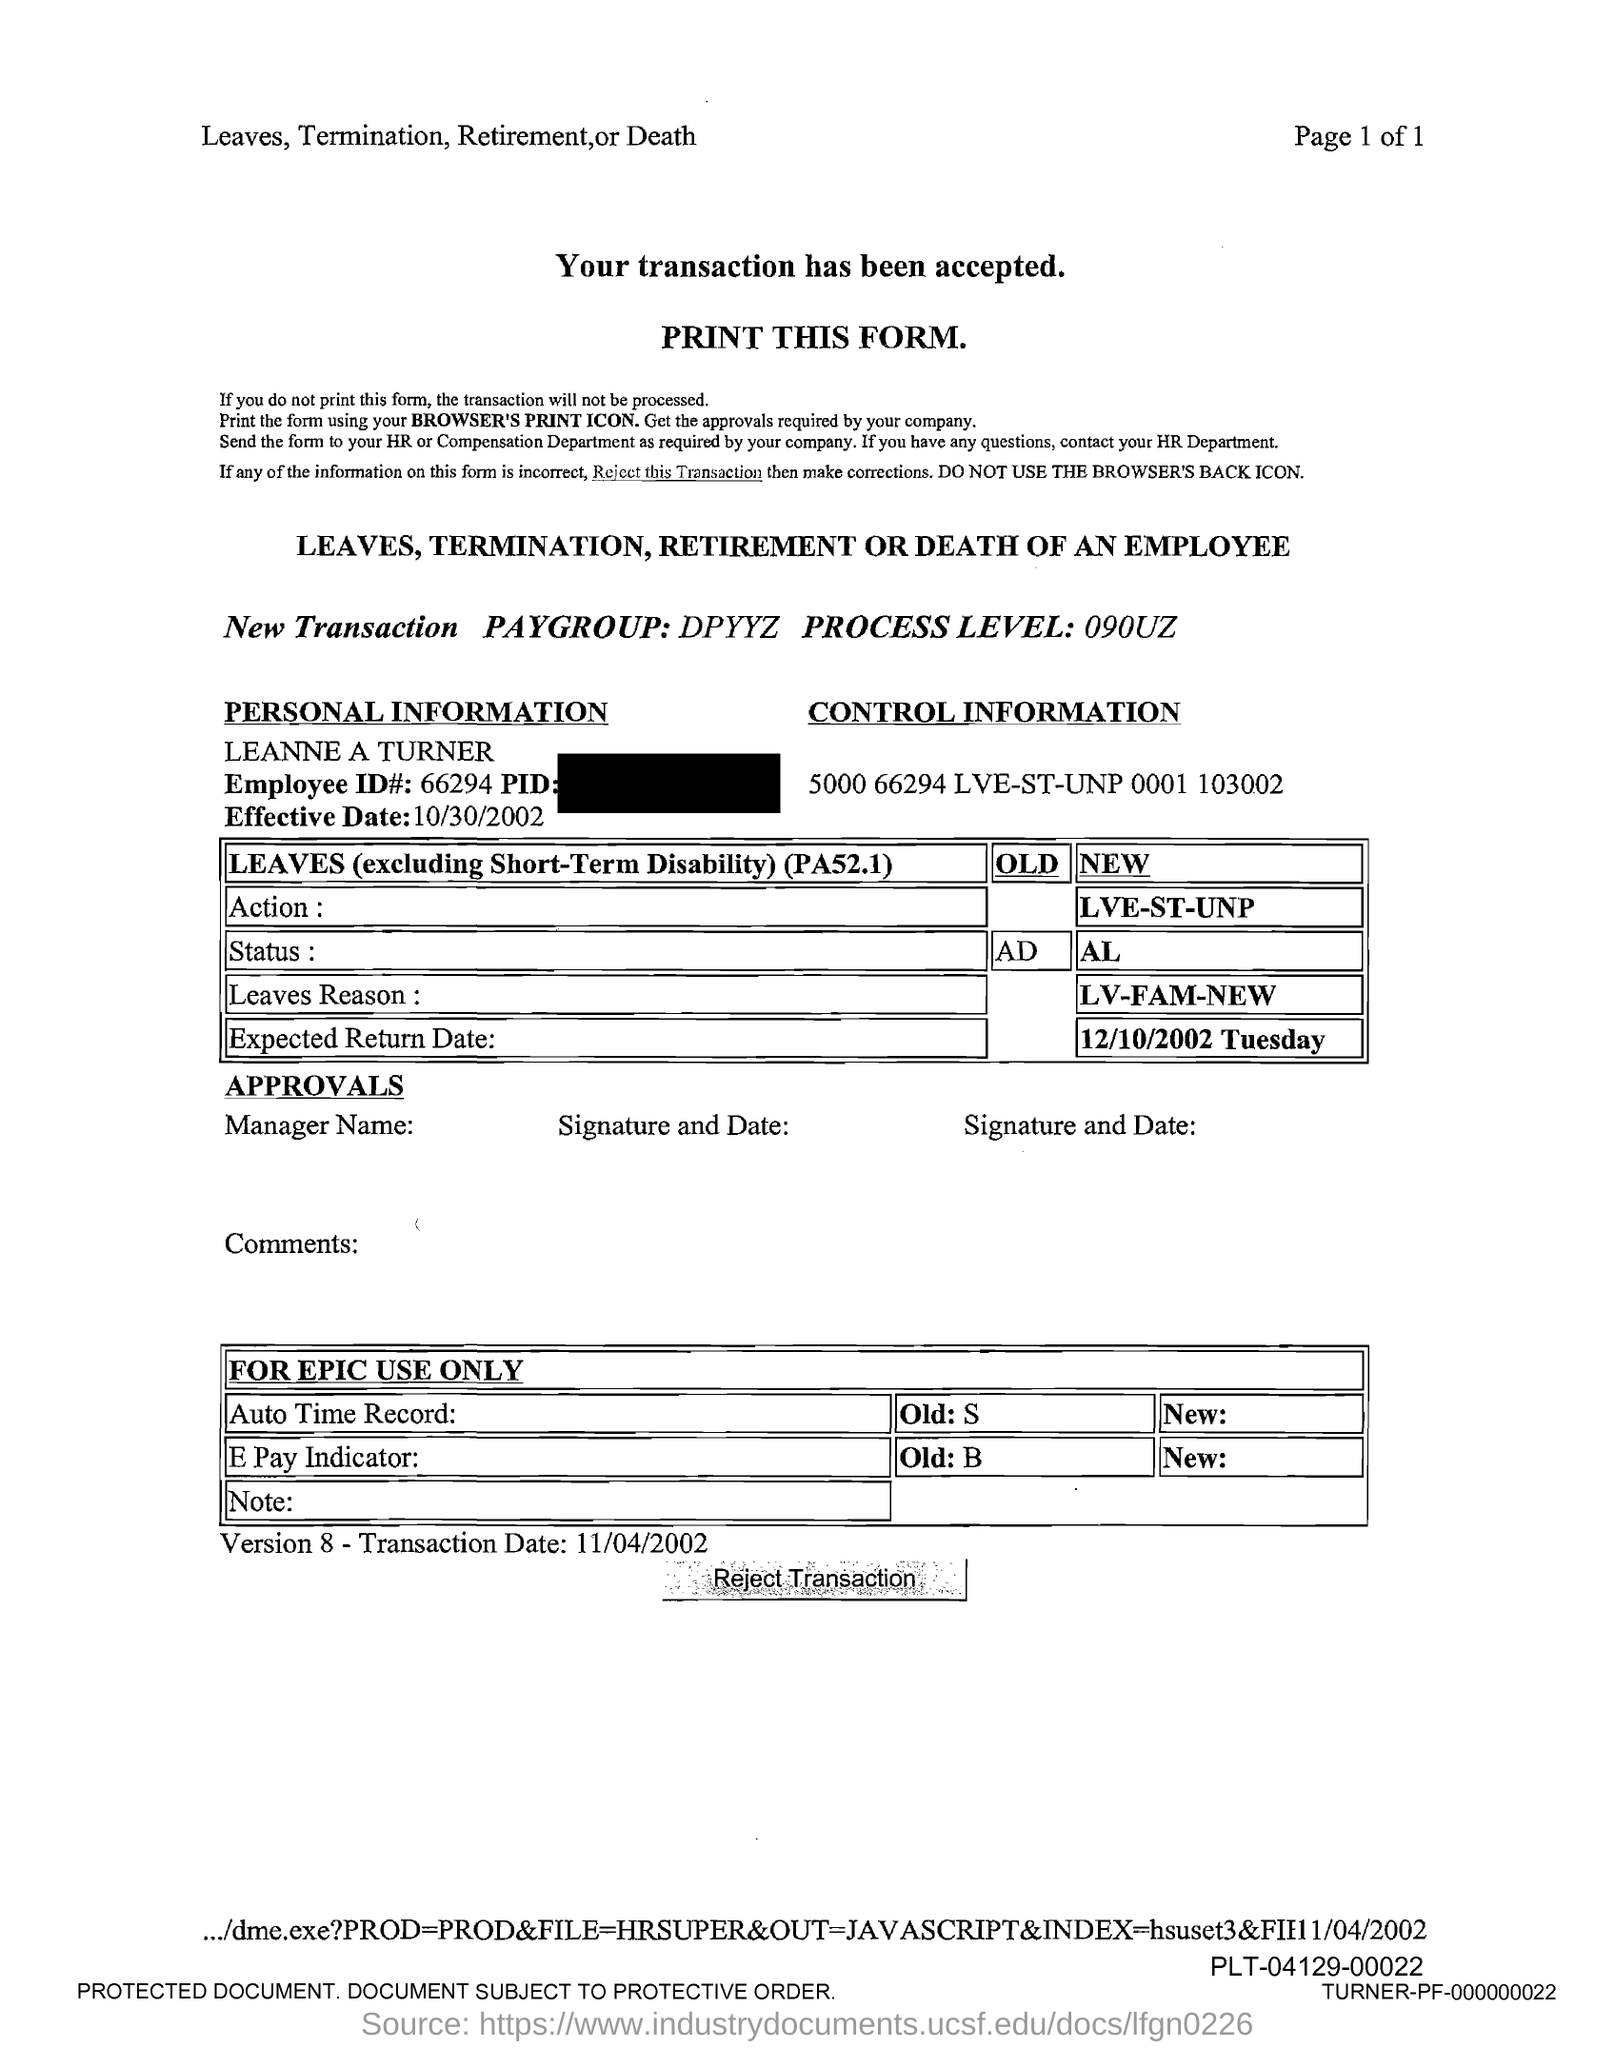Indicate a few pertinent items in this graphic. The question is asking what the employee ID number is, specifically the number 66294. 